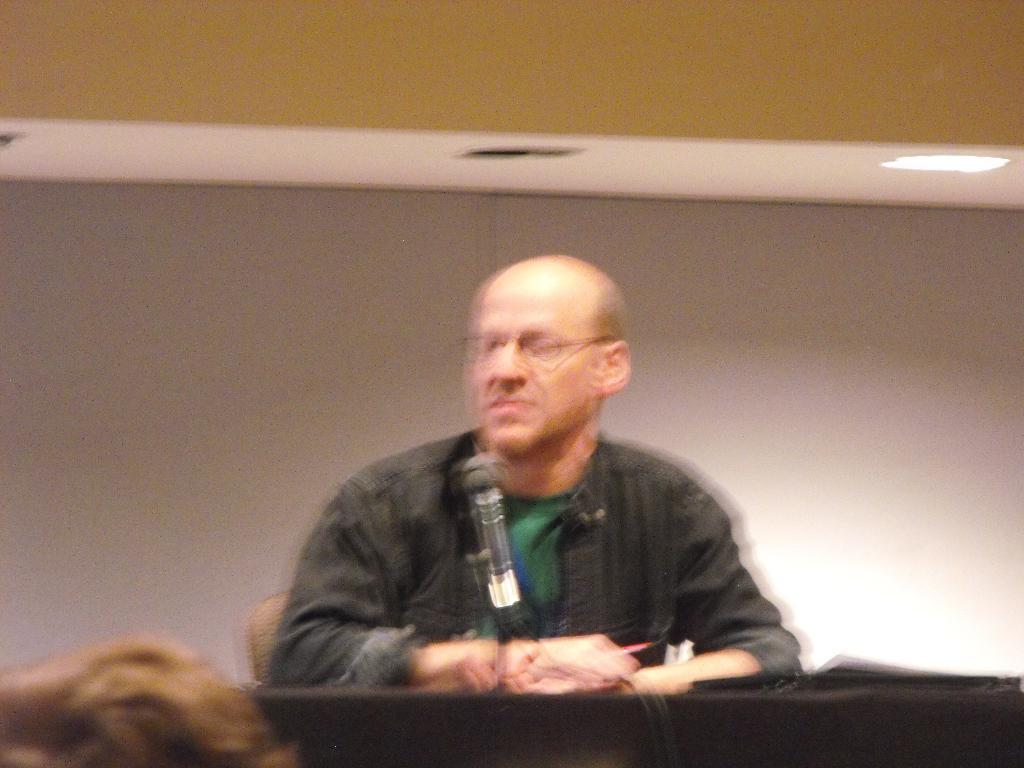What is the person in the image doing? The person is sitting in a chair. What object is beside the person? There is a mic beside the person. What piece of furniture is in the image? There is a table in the image. What is on the table? There are papers on the table. What can be seen in the background of the image? There is a wall and ceiling lights visible in the background. What type of lace is being used to cook in the image? There is no lace or cooking activity present in the image. How does the person ride the bike in the image? There is no bike present in the image. 